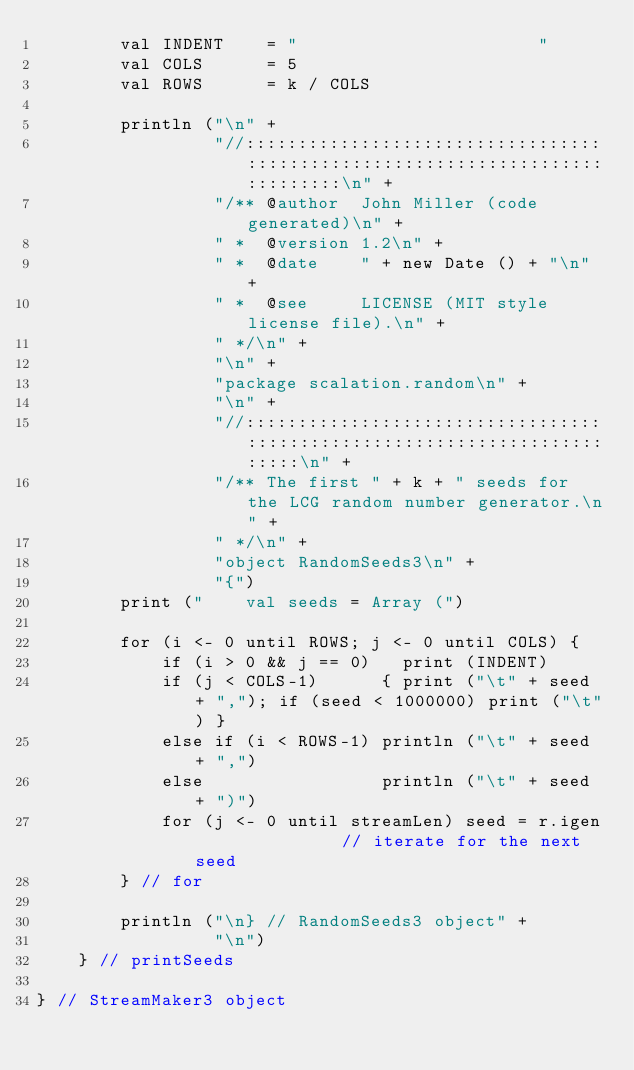<code> <loc_0><loc_0><loc_500><loc_500><_Scala_>        val INDENT    = "                       "
        val COLS      = 5
        val ROWS      = k / COLS

        println ("\n" +
                 "//:::::::::::::::::::::::::::::::::::::::::::::::::::::::::::::::::::::::::::::\n" +
                 "/** @author  John Miller (code generated)\n" +
                 " *  @version 1.2\n" +
                 " *  @date    " + new Date () + "\n" +
                 " *  @see     LICENSE (MIT style license file).\n" +
                 " */\n" +
                 "\n" +
                 "package scalation.random\n" +
                 "\n" +
                 "//:::::::::::::::::::::::::::::::::::::::::::::::::::::::::::::::::::::::::\n" +
                 "/** The first " + k + " seeds for the LCG random number generator.\n" +
                 " */\n" +
                 "object RandomSeeds3\n" +
                 "{")
        print ("    val seeds = Array (")

        for (i <- 0 until ROWS; j <- 0 until COLS) {
            if (i > 0 && j == 0)   print (INDENT)
            if (j < COLS-1)      { print ("\t" + seed + ","); if (seed < 1000000) print ("\t") }
            else if (i < ROWS-1) println ("\t" + seed + ",")
            else                 println ("\t" + seed + ")")
            for (j <- 0 until streamLen) seed = r.igen              // iterate for the next seed
        } // for

        println ("\n} // RandomSeeds3 object" +
                 "\n")
    } // printSeeds

} // StreamMaker3 object

</code> 